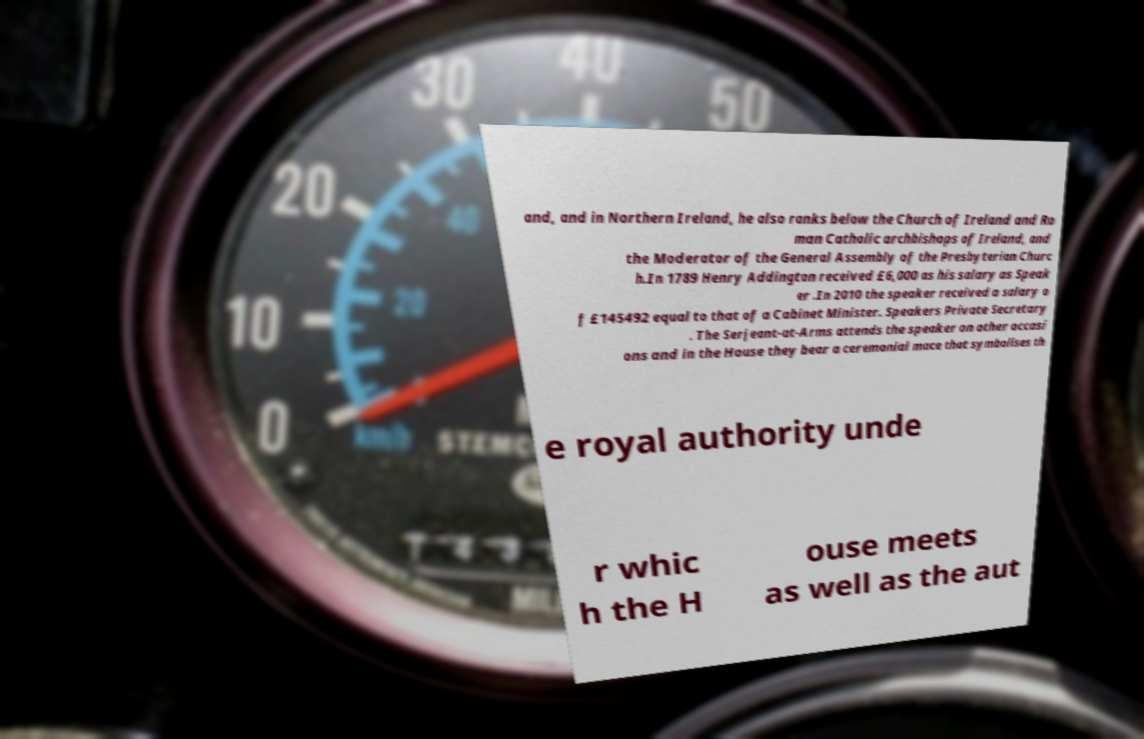There's text embedded in this image that I need extracted. Can you transcribe it verbatim? and, and in Northern Ireland, he also ranks below the Church of Ireland and Ro man Catholic archbishops of Ireland, and the Moderator of the General Assembly of the Presbyterian Churc h.In 1789 Henry Addington received £6,000 as his salary as Speak er .In 2010 the speaker received a salary o f £145492 equal to that of a Cabinet Minister. Speakers Private Secretary . The Serjeant-at-Arms attends the speaker on other occasi ons and in the House they bear a ceremonial mace that symbolises th e royal authority unde r whic h the H ouse meets as well as the aut 